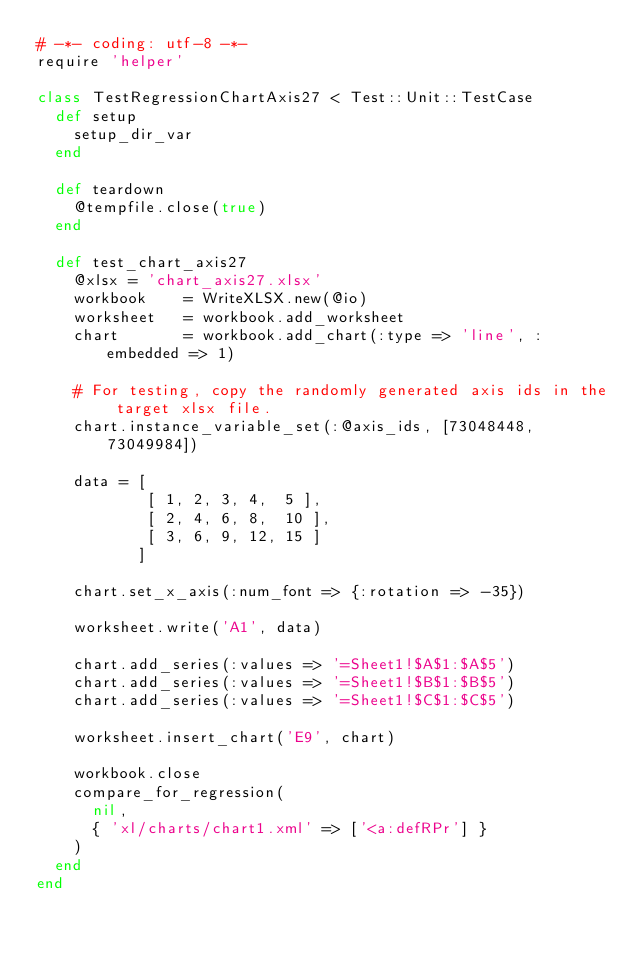Convert code to text. <code><loc_0><loc_0><loc_500><loc_500><_Ruby_># -*- coding: utf-8 -*-
require 'helper'

class TestRegressionChartAxis27 < Test::Unit::TestCase
  def setup
    setup_dir_var
  end

  def teardown
    @tempfile.close(true)
  end

  def test_chart_axis27
    @xlsx = 'chart_axis27.xlsx'
    workbook    = WriteXLSX.new(@io)
    worksheet   = workbook.add_worksheet
    chart       = workbook.add_chart(:type => 'line', :embedded => 1)

    # For testing, copy the randomly generated axis ids in the target xlsx file.
    chart.instance_variable_set(:@axis_ids, [73048448, 73049984])

    data = [
            [ 1, 2, 3, 4,  5 ],
            [ 2, 4, 6, 8,  10 ],
            [ 3, 6, 9, 12, 15 ]
           ]

    chart.set_x_axis(:num_font => {:rotation => -35})

    worksheet.write('A1', data)

    chart.add_series(:values => '=Sheet1!$A$1:$A$5')
    chart.add_series(:values => '=Sheet1!$B$1:$B$5')
    chart.add_series(:values => '=Sheet1!$C$1:$C$5')

    worksheet.insert_chart('E9', chart)

    workbook.close
    compare_for_regression(
      nil,
      { 'xl/charts/chart1.xml' => ['<a:defRPr'] }
    )
  end
end
</code> 